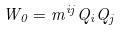Convert formula to latex. <formula><loc_0><loc_0><loc_500><loc_500>W _ { 0 } = m ^ { i j } Q _ { i } Q _ { j }</formula> 